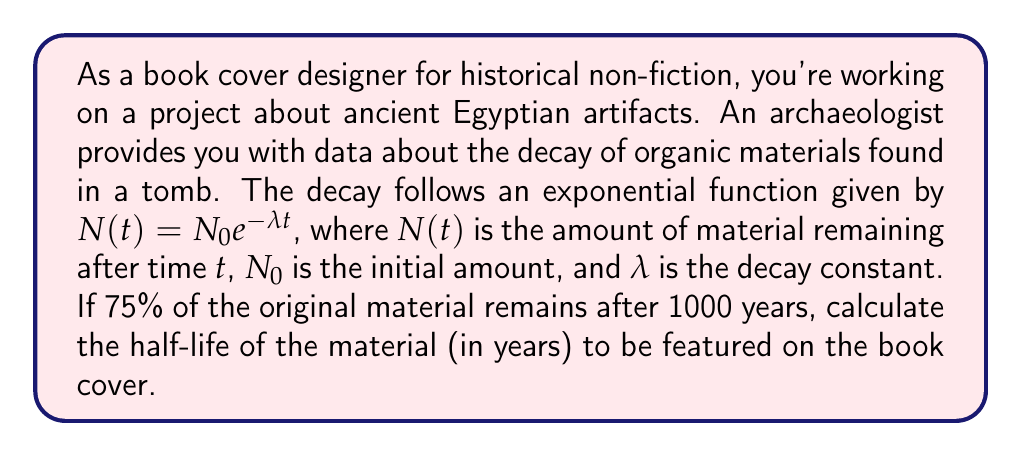Can you solve this math problem? To solve this problem, we'll follow these steps:

1) We're given that 75% of the material remains after 1000 years. Let's use this information in our equation:

   $N(1000) = 0.75N_0 = N_0e^{-1000\lambda}$

2) Dividing both sides by $N_0$:

   $0.75 = e^{-1000\lambda}$

3) Taking the natural logarithm of both sides:

   $\ln(0.75) = -1000\lambda$

4) Solving for $\lambda$:

   $\lambda = -\frac{\ln(0.75)}{1000} \approx 0.0002877$ per year

5) Now that we have $\lambda$, we can calculate the half-life. The half-life is the time it takes for half of the material to decay. In other words, it's the time $t$ when $N(t) = 0.5N_0$:

   $0.5 = e^{-\lambda t}$

6) Taking the natural logarithm of both sides:

   $\ln(0.5) = -\lambda t$

7) Solving for $t$:

   $t = -\frac{\ln(0.5)}{\lambda} = -\frac{\ln(0.5)}{0.0002877} \approx 2408.9$ years

Therefore, the half-life of the material is approximately 2409 years.
Answer: The half-life of the material is approximately 2409 years. 